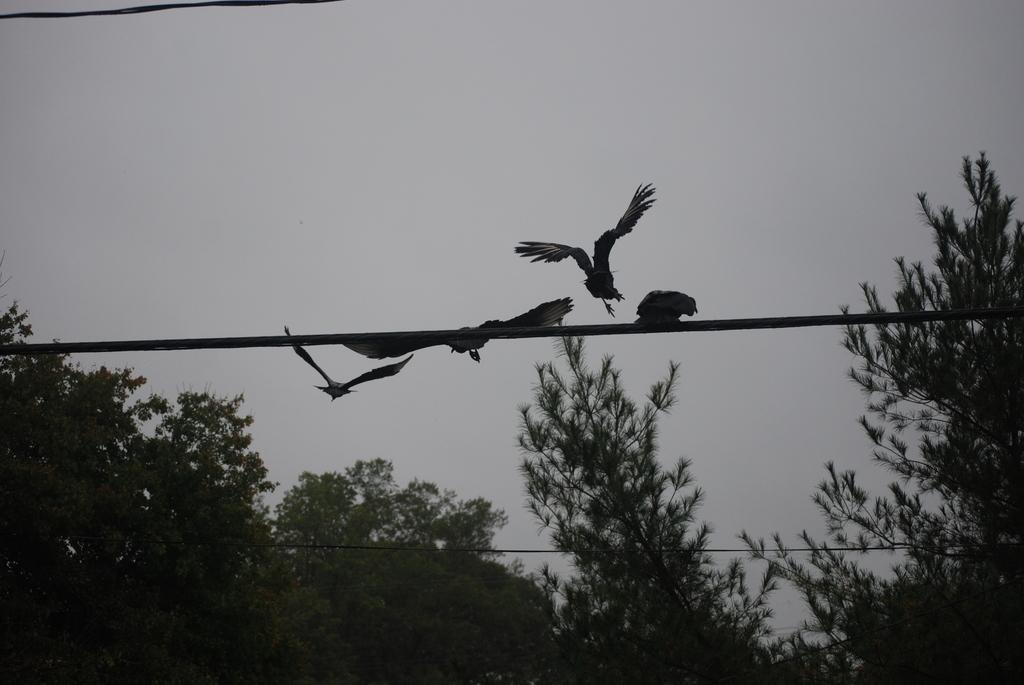What type of vegetation can be seen in the image? There are trees in the image. What else is present in the image besides the trees? There are wires in the image. Can you describe the bird in the image? A bird is flying in the sky in the image. Where is the station located in the image? There is no station present in the image. What does the mom say about the bird in the image? There is no mom present in the image, and therefore no comment can be attributed to her. 